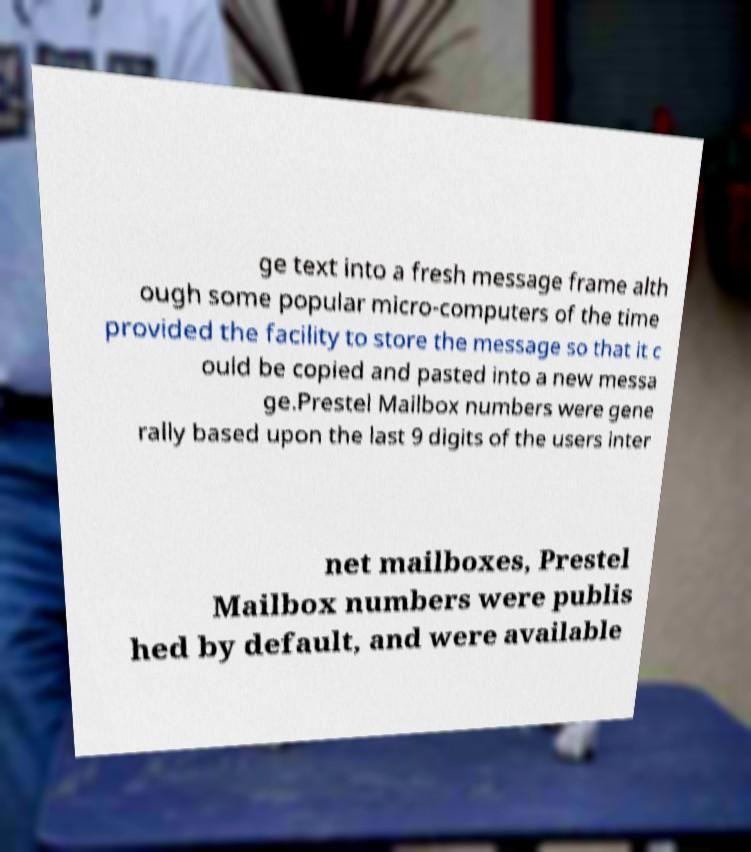Could you assist in decoding the text presented in this image and type it out clearly? ge text into a fresh message frame alth ough some popular micro-computers of the time provided the facility to store the message so that it c ould be copied and pasted into a new messa ge.Prestel Mailbox numbers were gene rally based upon the last 9 digits of the users inter net mailboxes, Prestel Mailbox numbers were publis hed by default, and were available 